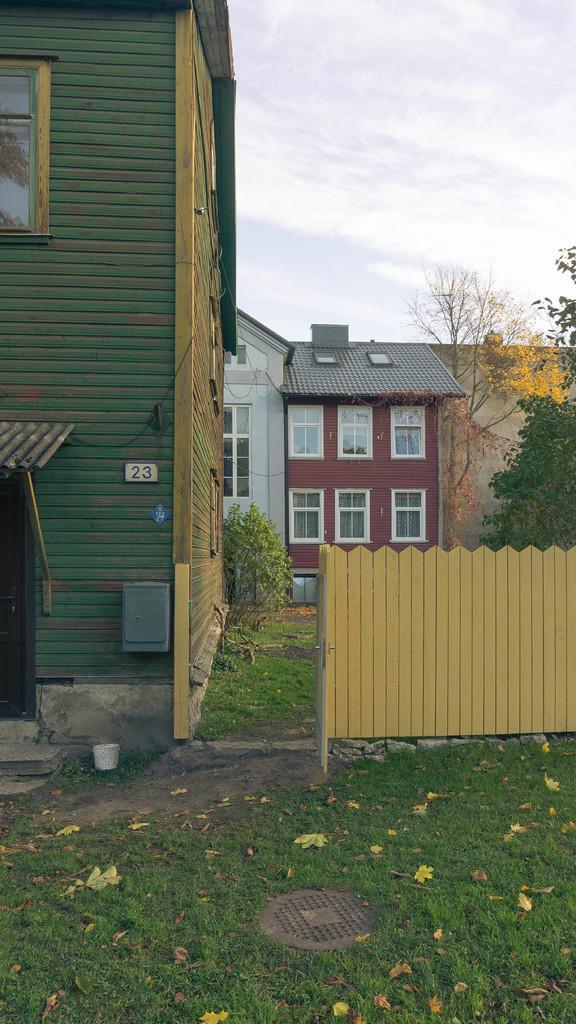Can you describe this image briefly? In this image I can see some grass, few leaves and the yellow colored railing. I can see few buildings and few trees which are yellow and green in color. In the background I can see the sky. 